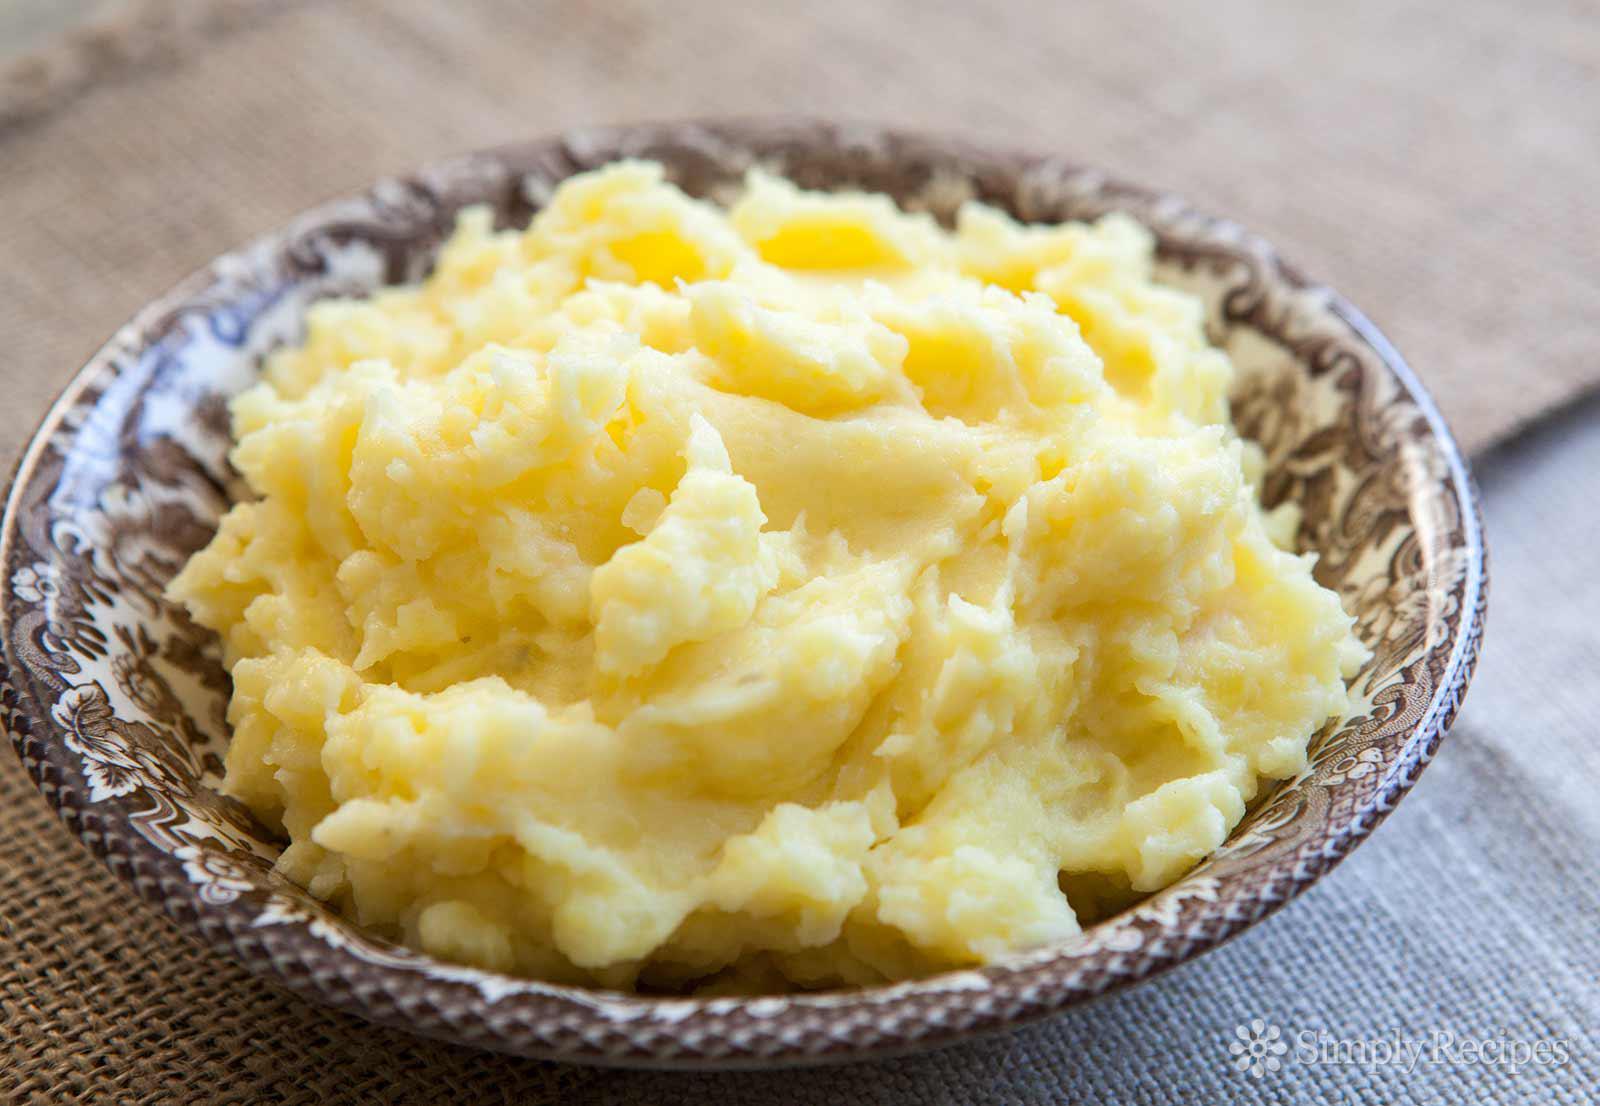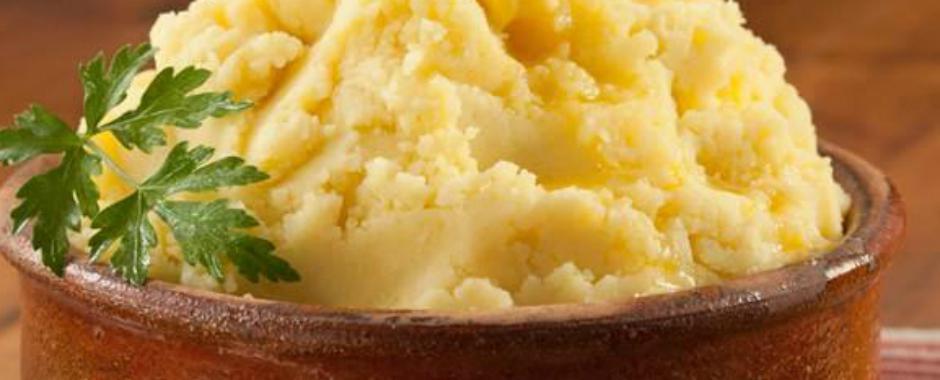The first image is the image on the left, the second image is the image on the right. Analyze the images presented: Is the assertion "The dish on the right contains a large piece of green garnish." valid? Answer yes or no. Yes. The first image is the image on the left, the second image is the image on the right. For the images shown, is this caption "An image shows a bowl of mashed potatoes garnished with one green sprig." true? Answer yes or no. Yes. 